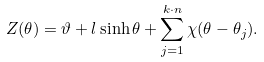Convert formula to latex. <formula><loc_0><loc_0><loc_500><loc_500>Z ( \theta ) = \vartheta + l \sinh \theta + \sum _ { j = 1 } ^ { k \cdot n } \chi ( \theta - \theta _ { j } ) .</formula> 